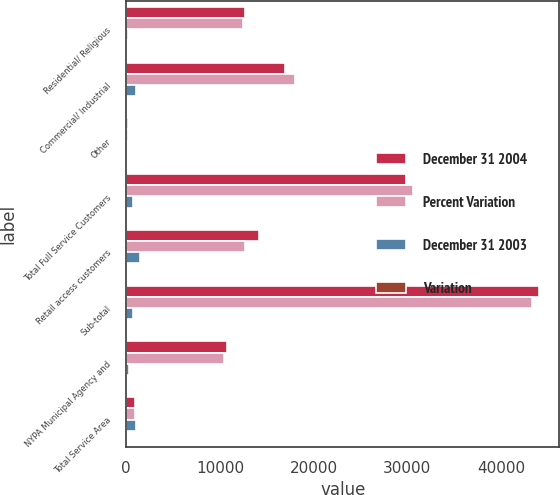Convert chart. <chart><loc_0><loc_0><loc_500><loc_500><stacked_bar_chart><ecel><fcel>Residential/ Religious<fcel>Commercial/ Industrial<fcel>Other<fcel>Total Full Service Customers<fcel>Retail access customers<fcel>Sub-total<fcel>NYPA Municipal Agency and<fcel>Total Service Area<nl><fcel>December 31 2004<fcel>12673<fcel>16966<fcel>229<fcel>29868<fcel>14143<fcel>44011<fcel>10730<fcel>883<nl><fcel>Percent Variation<fcel>12441<fcel>18033<fcel>154<fcel>30628<fcel>12637<fcel>43265<fcel>10470<fcel>883<nl><fcel>December 31 2003<fcel>232<fcel>1067<fcel>75<fcel>760<fcel>1506<fcel>746<fcel>260<fcel>1006<nl><fcel>Variation<fcel>1.9<fcel>5.9<fcel>48.7<fcel>2.5<fcel>11.9<fcel>1.7<fcel>2.5<fcel>1.9<nl></chart> 